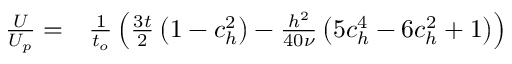<formula> <loc_0><loc_0><loc_500><loc_500>\begin{array} { r l } { \frac { U } { U _ { p } } = } & \frac { 1 } { t _ { o } } \left ( \frac { 3 t } { 2 } \left ( 1 - c _ { h } ^ { 2 } \right ) - \frac { h ^ { 2 } } { 4 0 \nu } \left ( 5 c _ { h } ^ { 4 } - 6 c _ { h } ^ { 2 } + 1 \right ) \right ) } \end{array}</formula> 